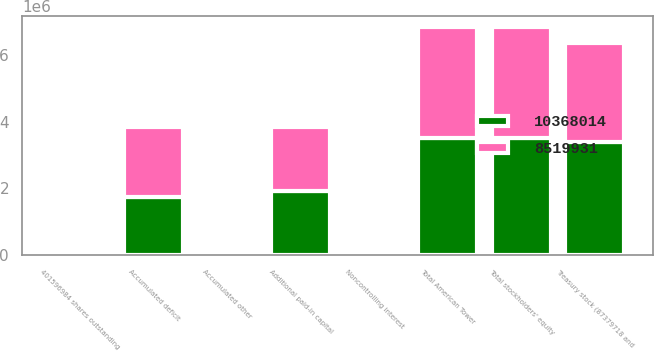<chart> <loc_0><loc_0><loc_500><loc_500><stacked_bar_chart><ecel><fcel>401596984 shares outstanding<fcel>Additional paid-in capital<fcel>Accumulated deficit<fcel>Accumulated other<fcel>Treasury stock (87379718 and<fcel>Total American Tower<fcel>Noncontrolling interest<fcel>Total stockholders' equity<nl><fcel>1.0368e+07<fcel>4860<fcel>1.92306e+06<fcel>1.7366e+06<fcel>38053<fcel>3.38197e+06<fcel>3.50144e+06<fcel>3114<fcel>3.50456e+06<nl><fcel>8.51993e+06<fcel>4797<fcel>1.92306e+06<fcel>2.10953e+06<fcel>12649<fcel>2.96118e+06<fcel>3.31508e+06<fcel>3043<fcel>3.31812e+06<nl></chart> 